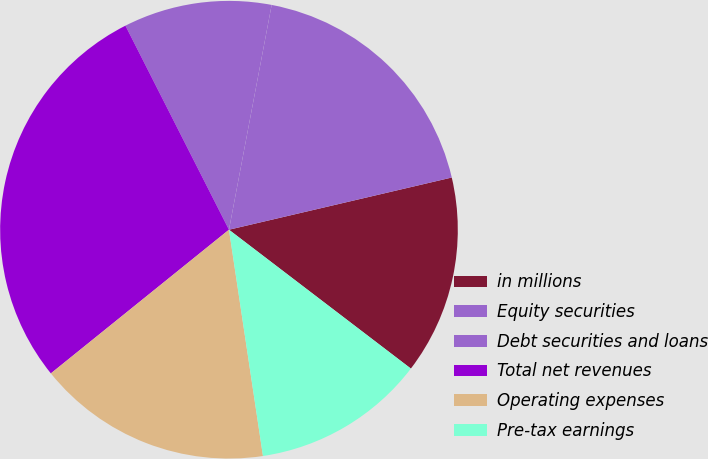Convert chart to OTSL. <chart><loc_0><loc_0><loc_500><loc_500><pie_chart><fcel>in millions<fcel>Equity securities<fcel>Debt securities and loans<fcel>Total net revenues<fcel>Operating expenses<fcel>Pre-tax earnings<nl><fcel>14.04%<fcel>18.35%<fcel>10.46%<fcel>28.33%<fcel>16.57%<fcel>12.25%<nl></chart> 